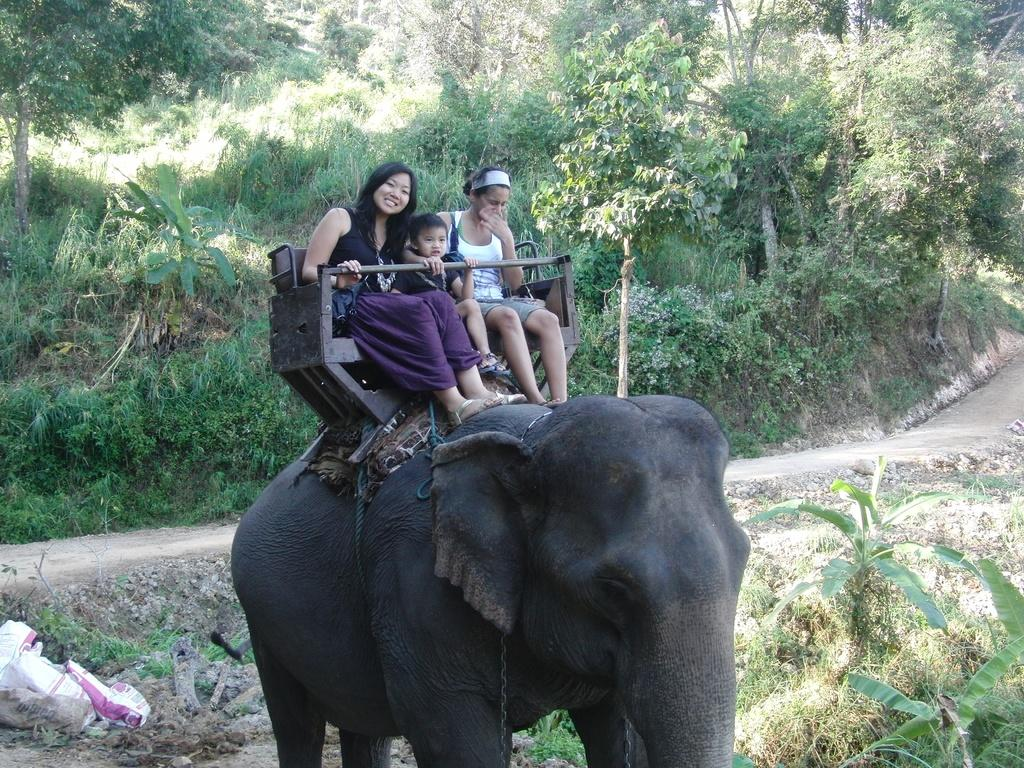How many people are in the image? There are three women in the image. What are the women doing in the image? The women are riding on an elephant. What type of yam can be seen in the image? There is no yam present in the image; it features three women riding on an elephant. Is there a jail visible in the image? No, there is no jail present in the image. 